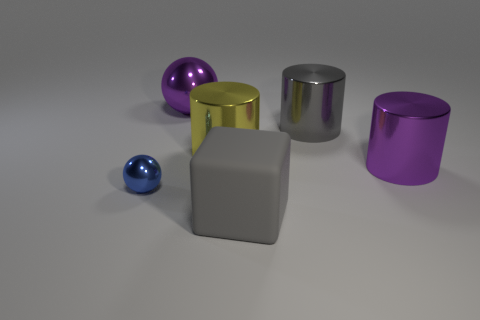There is a sphere on the left side of the ball that is behind the purple shiny cylinder; what color is it?
Provide a short and direct response. Blue. What number of other objects are there of the same material as the blue sphere?
Give a very brief answer. 4. How many other things are there of the same color as the large cube?
Your answer should be very brief. 1. What is the ball that is on the left side of the metallic ball behind the tiny blue shiny sphere made of?
Make the answer very short. Metal. Are there any large gray shiny cylinders?
Your answer should be compact. Yes. There is a purple object that is on the left side of the metallic cylinder that is right of the large gray cylinder; how big is it?
Provide a short and direct response. Large. Are there more matte cubes left of the tiny thing than matte cubes that are behind the gray block?
Provide a succinct answer. No. How many balls are yellow objects or big rubber things?
Offer a very short reply. 0. Is there any other thing that has the same size as the gray cube?
Your answer should be compact. Yes. Is the shape of the small object that is behind the large rubber thing the same as  the gray shiny object?
Keep it short and to the point. No. 